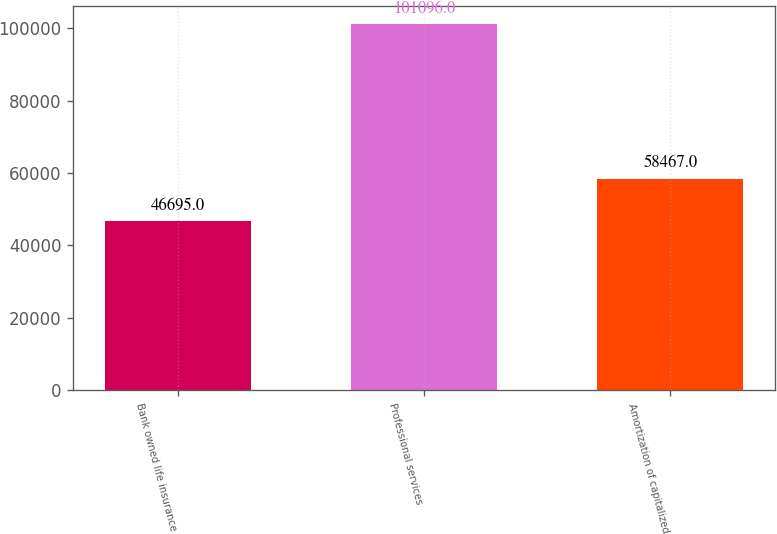Convert chart to OTSL. <chart><loc_0><loc_0><loc_500><loc_500><bar_chart><fcel>Bank owned life insurance<fcel>Professional services<fcel>Amortization of capitalized<nl><fcel>46695<fcel>101096<fcel>58467<nl></chart> 